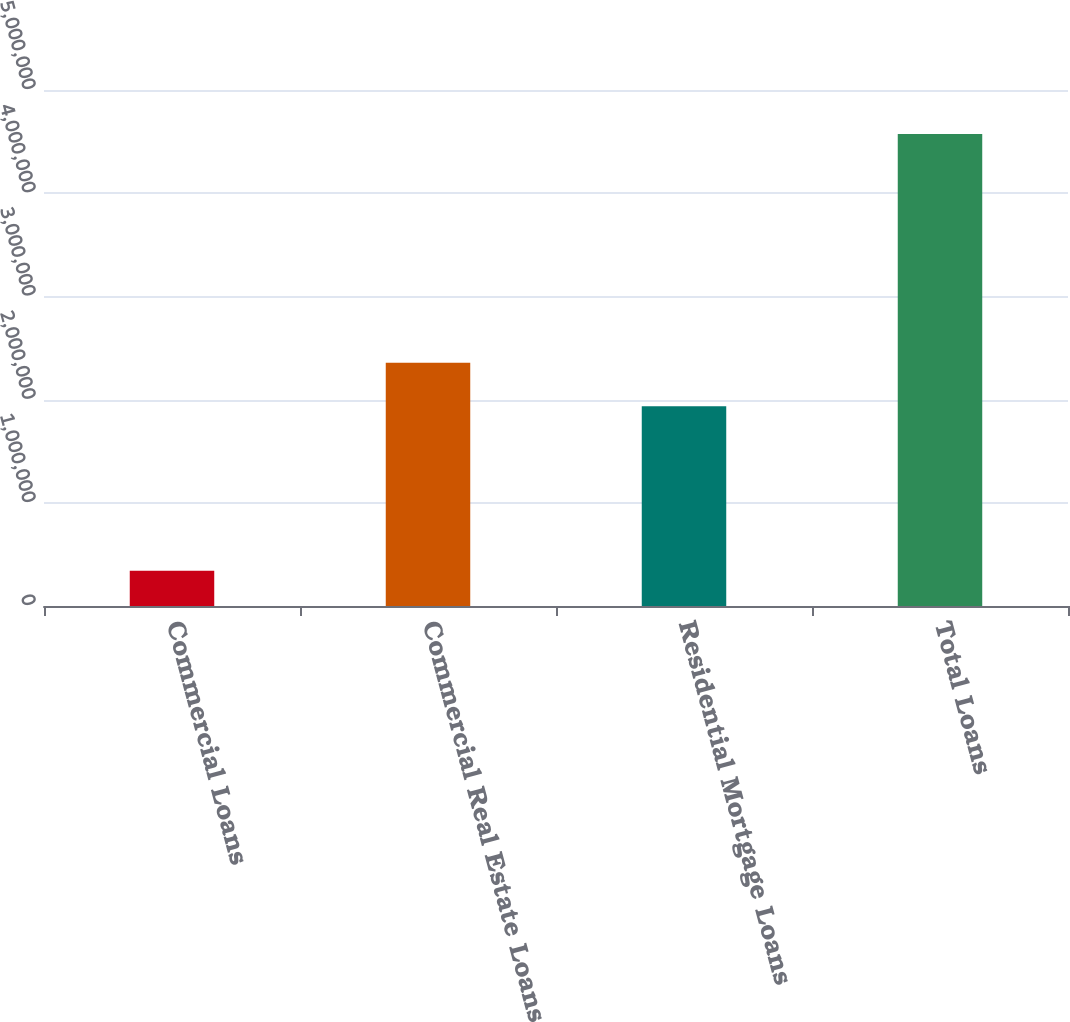Convert chart to OTSL. <chart><loc_0><loc_0><loc_500><loc_500><bar_chart><fcel>Commercial Loans<fcel>Commercial Real Estate Loans<fcel>Residential Mortgage Loans<fcel>Total Loans<nl><fcel>342726<fcel>2.35763e+06<fcel>1.93454e+06<fcel>4.57356e+06<nl></chart> 